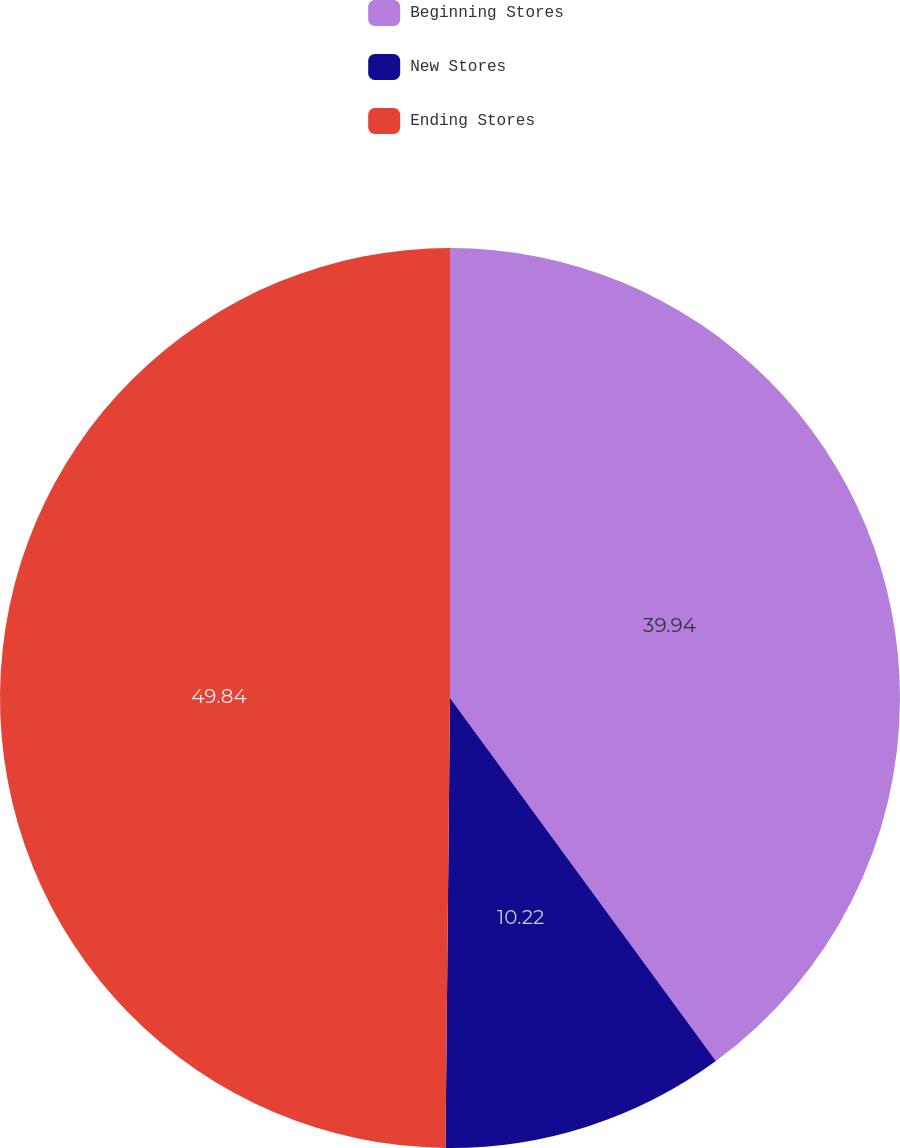Convert chart to OTSL. <chart><loc_0><loc_0><loc_500><loc_500><pie_chart><fcel>Beginning Stores<fcel>New Stores<fcel>Ending Stores<nl><fcel>39.94%<fcel>10.22%<fcel>49.84%<nl></chart> 